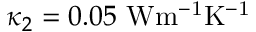<formula> <loc_0><loc_0><loc_500><loc_500>\kappa _ { 2 } = 0 . 0 5 { W m ^ { - 1 } K ^ { - 1 } }</formula> 